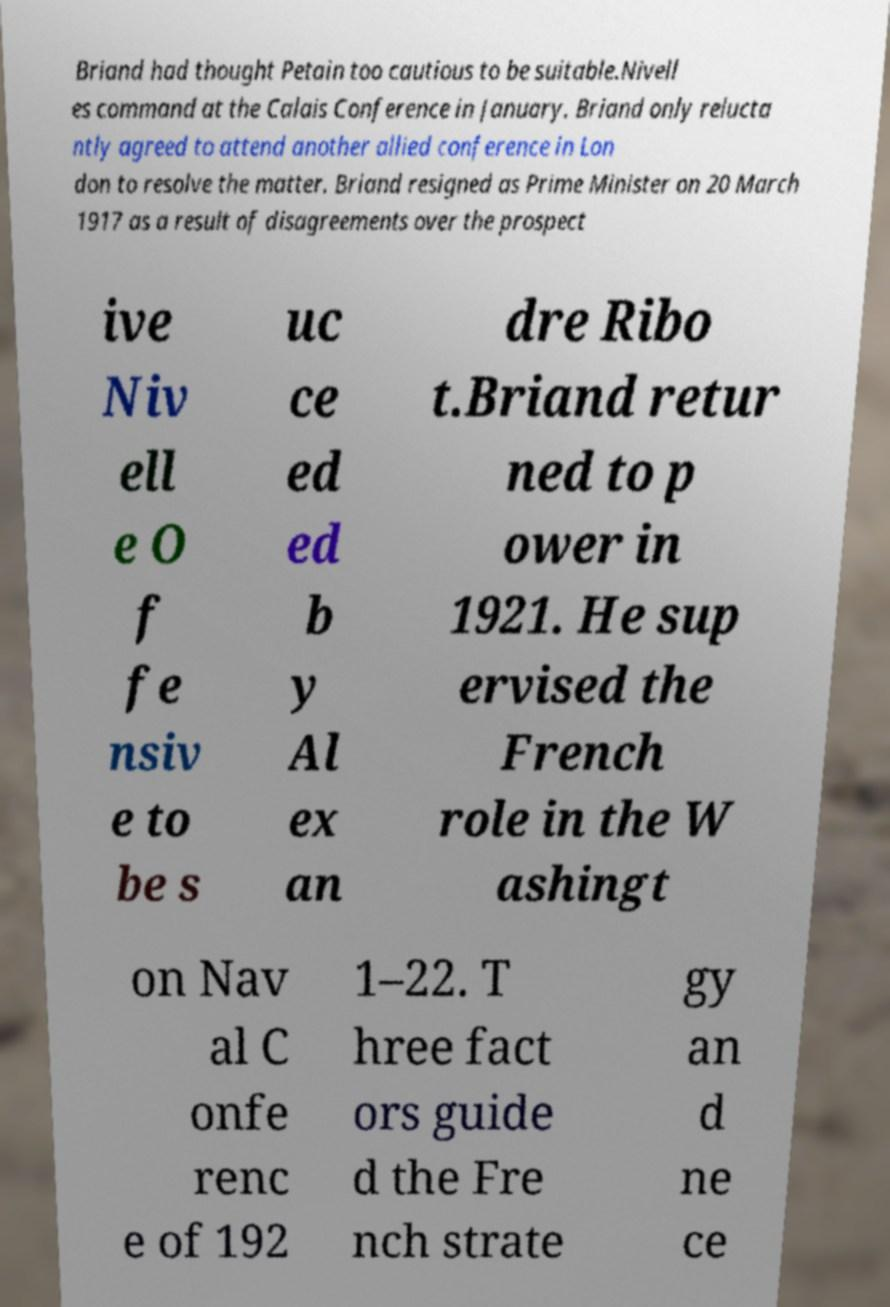Can you read and provide the text displayed in the image?This photo seems to have some interesting text. Can you extract and type it out for me? Briand had thought Petain too cautious to be suitable.Nivell es command at the Calais Conference in January. Briand only relucta ntly agreed to attend another allied conference in Lon don to resolve the matter. Briand resigned as Prime Minister on 20 March 1917 as a result of disagreements over the prospect ive Niv ell e O f fe nsiv e to be s uc ce ed ed b y Al ex an dre Ribo t.Briand retur ned to p ower in 1921. He sup ervised the French role in the W ashingt on Nav al C onfe renc e of 192 1–22. T hree fact ors guide d the Fre nch strate gy an d ne ce 